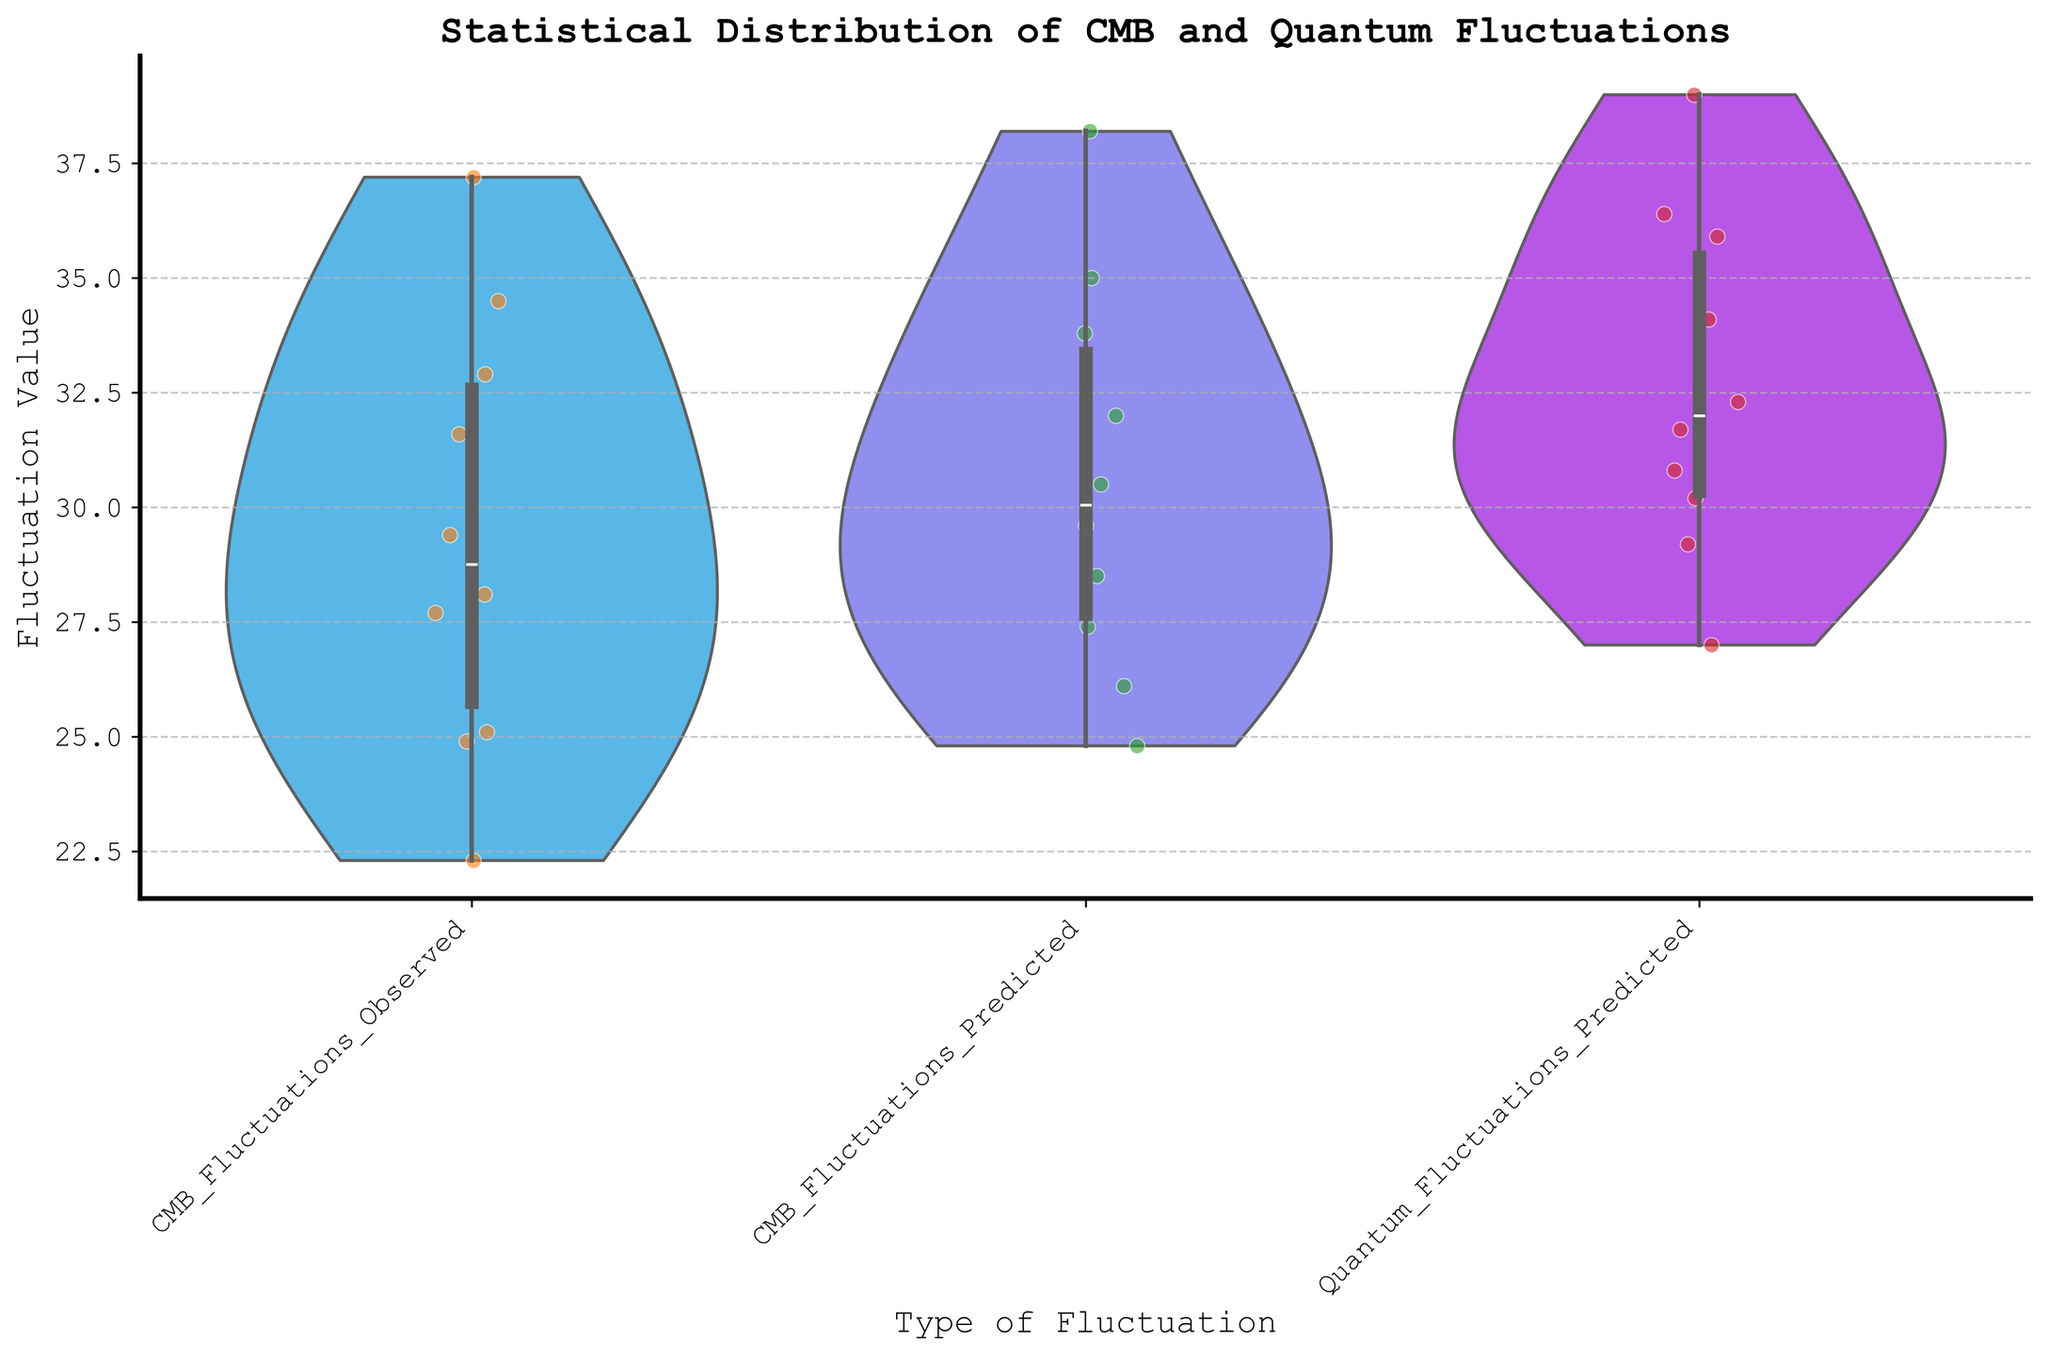What is the title of the figure? The title of the figure is displayed at the top center. It reads "Statistical Distribution of CMB and Quantum Fluctuations".
Answer: Statistical Distribution of CMB and Quantum Fluctuations How many different types of fluctuations are displayed in the figure? The figure has three different labels on the x-axis: "CMB_Fluctuations_Observed", "CMB_Fluctuations_Predicted", and "Quantum_Fluctuations_Predicted", indicating three types.
Answer: 3 What color palette is used in the figure? The figure uses the "cool" color palette as indicated by the aesthetic style in the plot. This usually consists of shades of blue, cyan, and green.
Answer: Cool color palette What's the range of the fluctuation values for "CMB_Fluctuations_Observed"? Looking at the violin plot for "CMB_Fluctuations_Observed", the range extends from approximately 22 to 38.
Answer: Approximately 22 to 38 Which type of fluctuation has the highest median value? The median value can be determined from the central bands in each box plot overlay. "Quantum_Fluctuations_Predicted" has the highest median, hovering around 35.
Answer: Quantum_Fluctuations_Predicted What is the interquartile range (IQR) for "CMB_Fluctuations_Predicted"? The IQR is calculated as the difference between the 75th percentile and the 25th percentile. For "CMB_Fluctuations_Predicted", the boxes in the plot suggest this IQR is approximately from 28 to 34.
Answer: Approximately 6 Compare the spread of the "CMB_Fluctuations_Observed" and "Quantum_Fluctuations_Predicted". By examining the width and shape of the violin plots, the spread for "Quantum_Fluctuations_Predicted" appears slightly wider (more varied) than "CMB_Fluctuations_Observed".
Answer: Quantum_Fluctuations_Predicted has more spread Does the observed CMB fluctuation data suggest outliers? By looking at the 'scatter' points in the "CMB_Fluctuations_Observed" violin plot, there appear to be no points that stand out significantly from the overall distribution, suggesting no notable outliers.
Answer: No Are the observed CMB fluctuations generally higher or lower than the predicted CMB fluctuations? Comparing the central tendencies (medians) and overall range of "CMB_Fluctuations_Observed" and "CMB_Fluctuations_Predicted", the observed values are slightly lower.
Answer: Generally lower Which fluctuation type shows the least variability? Variability is suggested by the width of the violin plot. "CMB_Fluctuations_Predicted" has the least width, indicating lower variability.
Answer: CMB_Fluctuations_Predicted 